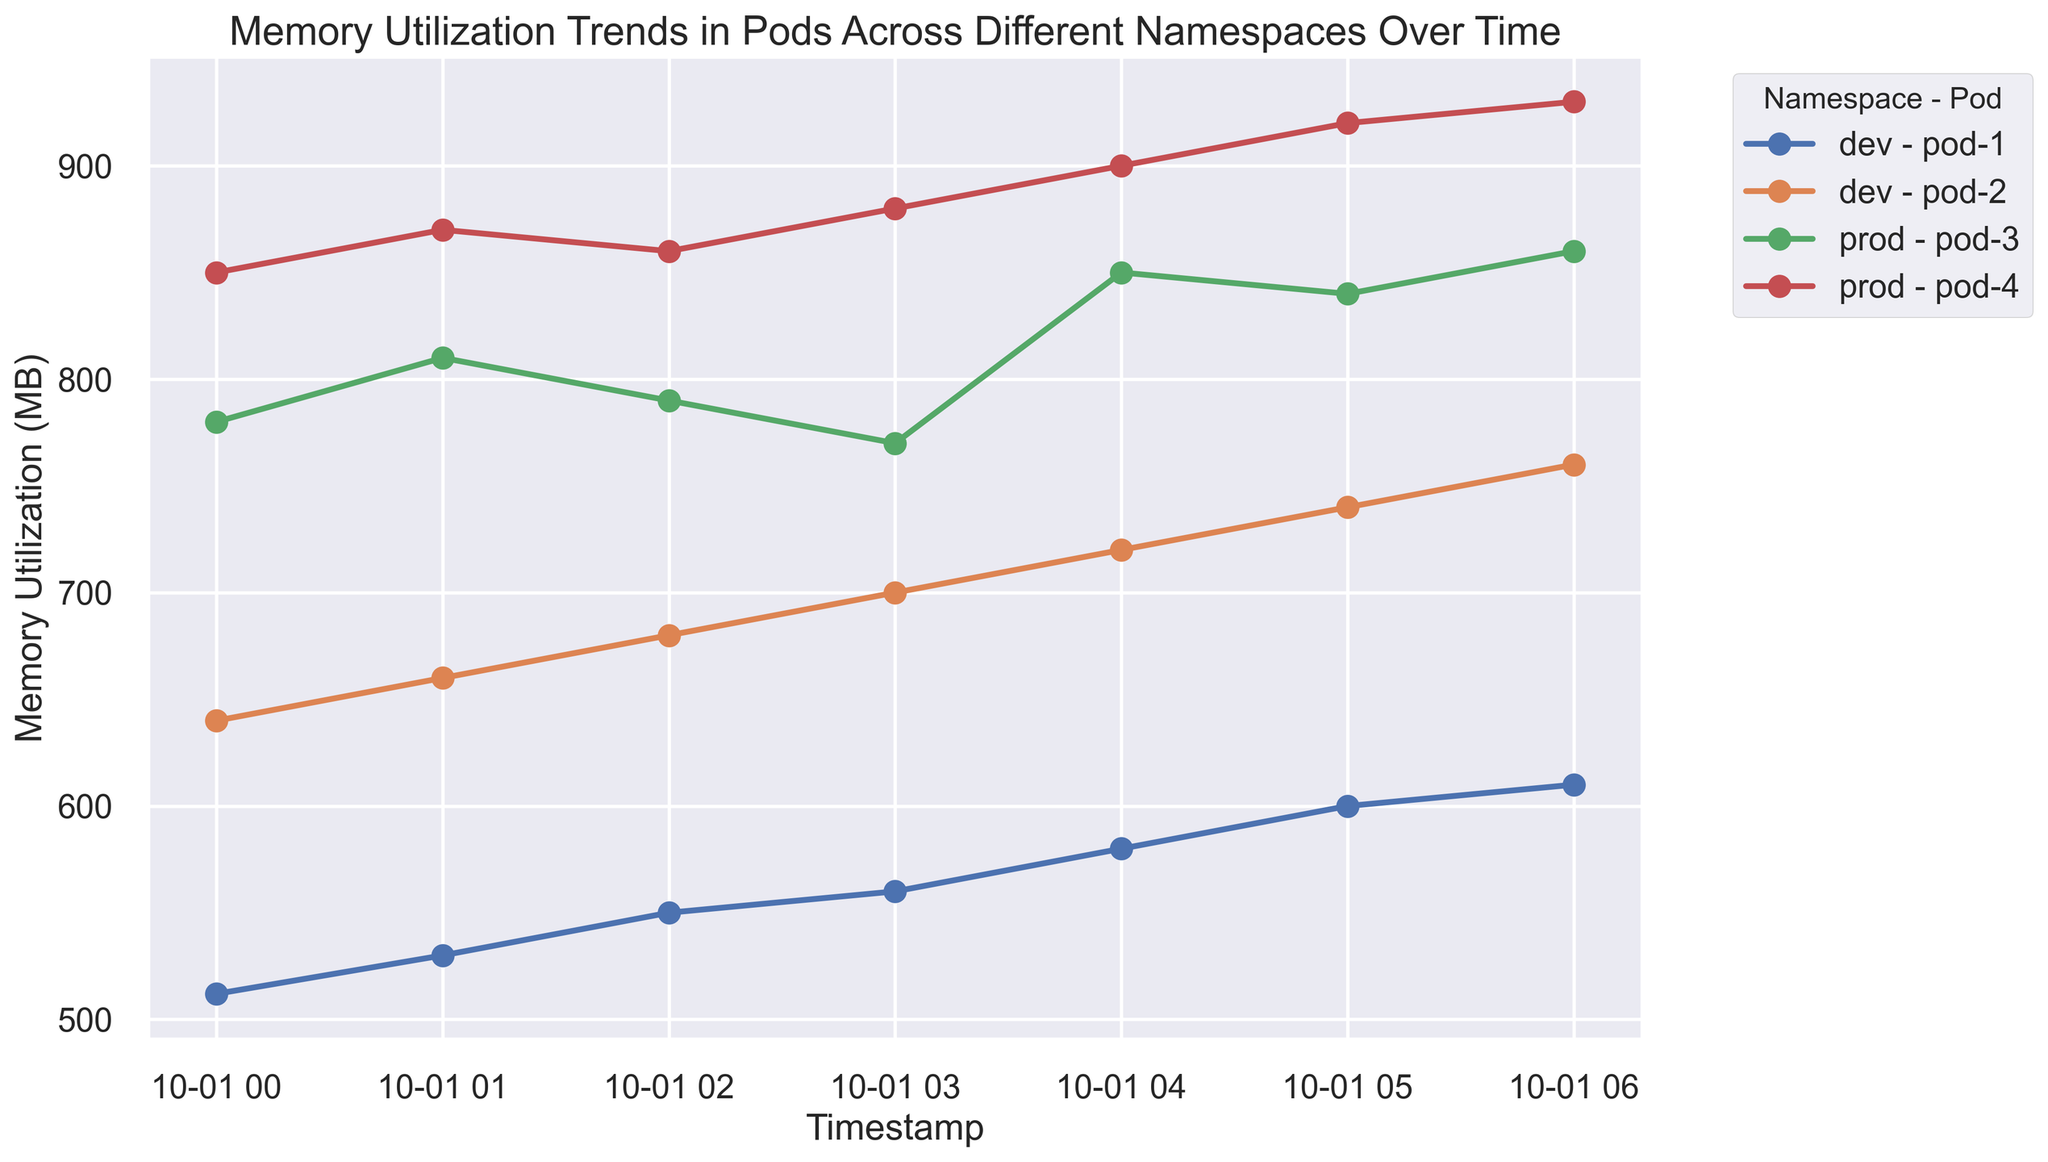What is the highest memory utilization observed for pod-4 in the prod namespace? Check the highest point on the line corresponding to pod-4 in the prod namespace.
Answer: 930 MB Which pod in the dev namespace started with the highest memory utilization at the beginning of the observation period? Look at the first timestamp and compare the memory utilization values of pod-1 and pod-2 in the dev namespace. Pod-2 has higher memory utilization.
Answer: pod-2 During which hour did pod-1 in the dev namespace experience the largest increase in memory utilization? Calculate the differences in memory utilization between consecutive timestamps for pod-1 in the dev namespace and identify the maximum increase. From 2023-10-01T04:00:00Z to 2023-10-01T05:00:00Z, the increase is 600 - 580 = 20 MB.
Answer: 2023-10-01T04:00:00Z to 2023-10-01T05:00:00Z How does the memory utilization trend of pod-3 in the prod namespace compare to pod-1 in the dev namespace? Observe the general pattern/trend of the lines for pod-3 in prod and pod-1 in dev namespaces. Pod-3 shows a generally increasing trend but with small fluctuations, while pod-1 shows a more steady and slightly increasing trend.
Answer: Pod-3 has fluctuating increases; pod-1 has a steady increase Which namespace has the highest average memory utilization across all pods at the last timestamp? At the last timestamp, sum the memory utilization of all pods in the dev namespace and divide by the number of pods; do the same for the prod namespace. Compare the average values. Prod: (860 + 930)/2 = 895 MB. Dev: (610 + 760)/2 = 685 MB.
Answer: prod By how much did the memory utilization of pod-2 in the dev namespace increase from the first to the last recorded timestamp? Subtract the initial memory utilization value of pod-2 in the dev namespace from the final value. 760 - 640 = 120 MB.
Answer: 120 MB At which timestamp did pod-3 in the prod namespace reach its peak memory utilization? Identify the highest point on the line for pod-3 in the prod namespace.
Answer: 2023-10-01T06:00:00Z Which pod had the lowest memory utilization at 2023-10-01T02:00:00Z? Compare memory utilization values for all pods at 2023-10-01T02:00:00Z and identify the lowest.
Answer: pod-1 in dev How does the increase in memory utilization of pod-2 in the dev namespace compare to that of pod-3 in the prod namespace from 2023-10-01T00:00:00Z to 2023-10-01T06:00:00Z? Calculate the increase for both pods: pod-2 in dev (760 - 640 = 120 MB), pod-3 in prod (860 - 780 = 80 MB). Compare the two increases.
Answer: Pod-2 increased more by 40 MB 